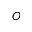Convert formula to latex. <formula><loc_0><loc_0><loc_500><loc_500>O</formula> 